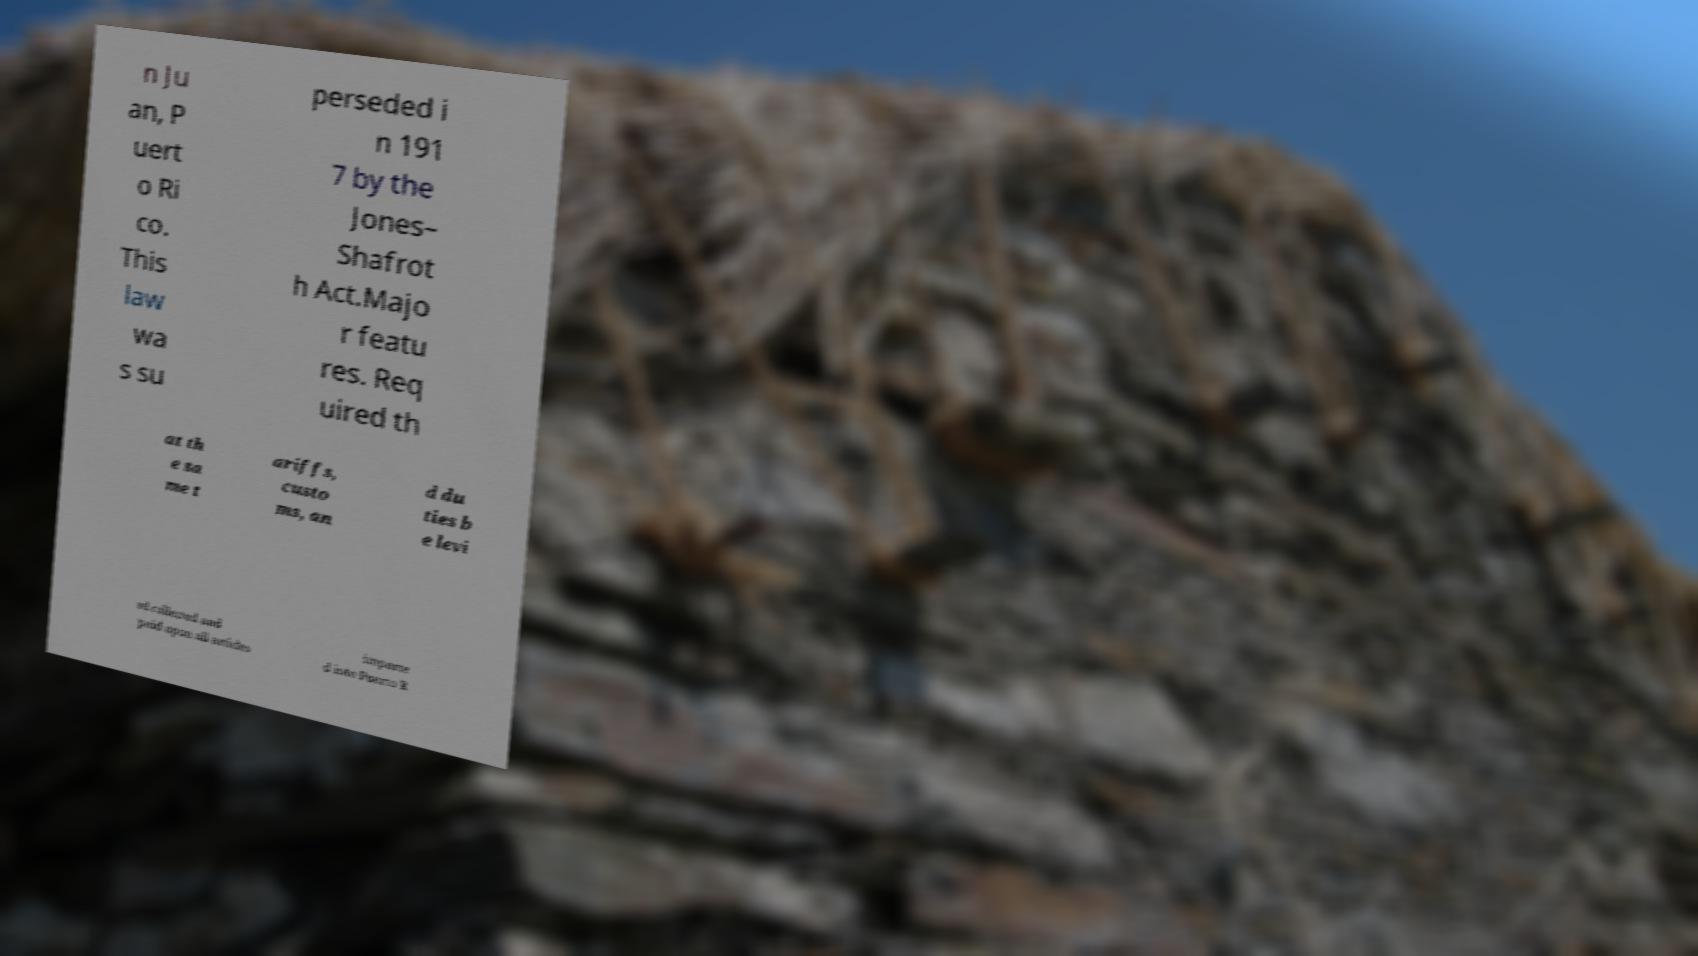There's text embedded in this image that I need extracted. Can you transcribe it verbatim? n Ju an, P uert o Ri co. This law wa s su perseded i n 191 7 by the Jones– Shafrot h Act.Majo r featu res. Req uired th at th e sa me t ariffs, custo ms, an d du ties b e levi ed collected and paid upon all articles importe d into Puerto R 